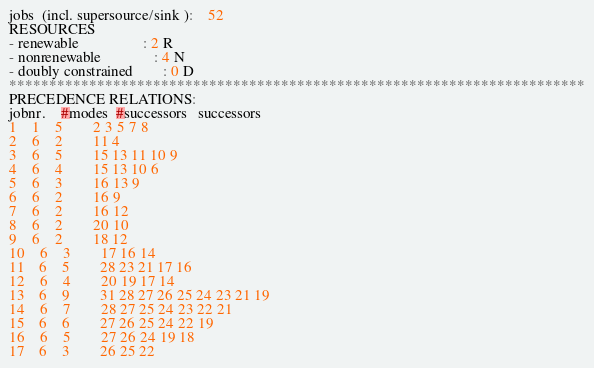Convert code to text. <code><loc_0><loc_0><loc_500><loc_500><_ObjectiveC_>jobs  (incl. supersource/sink ):	52
RESOURCES
- renewable                 : 2 R
- nonrenewable              : 4 N
- doubly constrained        : 0 D
************************************************************************
PRECEDENCE RELATIONS:
jobnr.    #modes  #successors   successors
1	1	5		2 3 5 7 8 
2	6	2		11 4 
3	6	5		15 13 11 10 9 
4	6	4		15 13 10 6 
5	6	3		16 13 9 
6	6	2		16 9 
7	6	2		16 12 
8	6	2		20 10 
9	6	2		18 12 
10	6	3		17 16 14 
11	6	5		28 23 21 17 16 
12	6	4		20 19 17 14 
13	6	9		31 28 27 26 25 24 23 21 19 
14	6	7		28 27 25 24 23 22 21 
15	6	6		27 26 25 24 22 19 
16	6	5		27 26 24 19 18 
17	6	3		26 25 22 </code> 